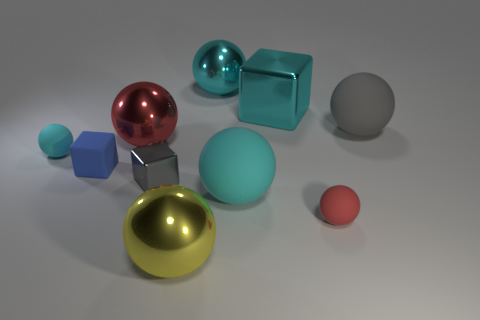Subtract all blue rubber cubes. How many cubes are left? 2 Subtract all purple cylinders. How many red spheres are left? 2 Subtract 2 spheres. How many spheres are left? 5 Subtract all red balls. How many balls are left? 5 Subtract all cubes. How many objects are left? 7 Subtract all brown cubes. Subtract all brown balls. How many cubes are left? 3 Subtract all large cyan matte balls. Subtract all gray metallic things. How many objects are left? 8 Add 9 large cubes. How many large cubes are left? 10 Add 2 metallic objects. How many metallic objects exist? 7 Subtract 0 green balls. How many objects are left? 10 